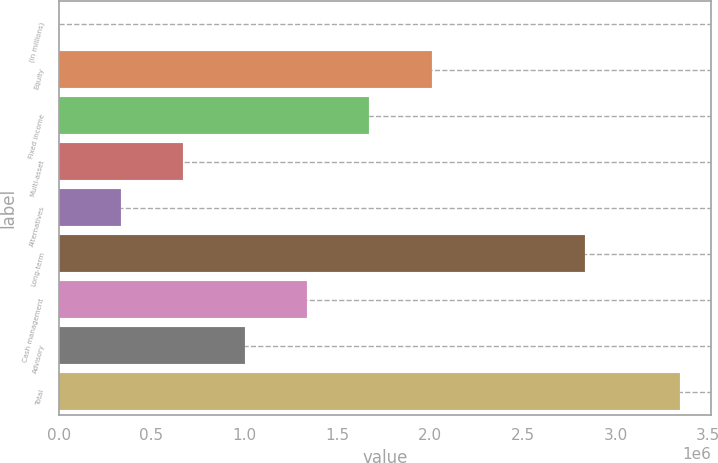Convert chart to OTSL. <chart><loc_0><loc_0><loc_500><loc_500><bar_chart><fcel>(in millions)<fcel>Equity<fcel>Fixed income<fcel>Multi-asset<fcel>Alternatives<fcel>Long-term<fcel>Cash management<fcel>Advisory<fcel>Total<nl><fcel>2009<fcel>2.00856e+06<fcel>1.67413e+06<fcel>670858<fcel>336434<fcel>2.83581e+06<fcel>1.33971e+06<fcel>1.00528e+06<fcel>3.34626e+06<nl></chart> 